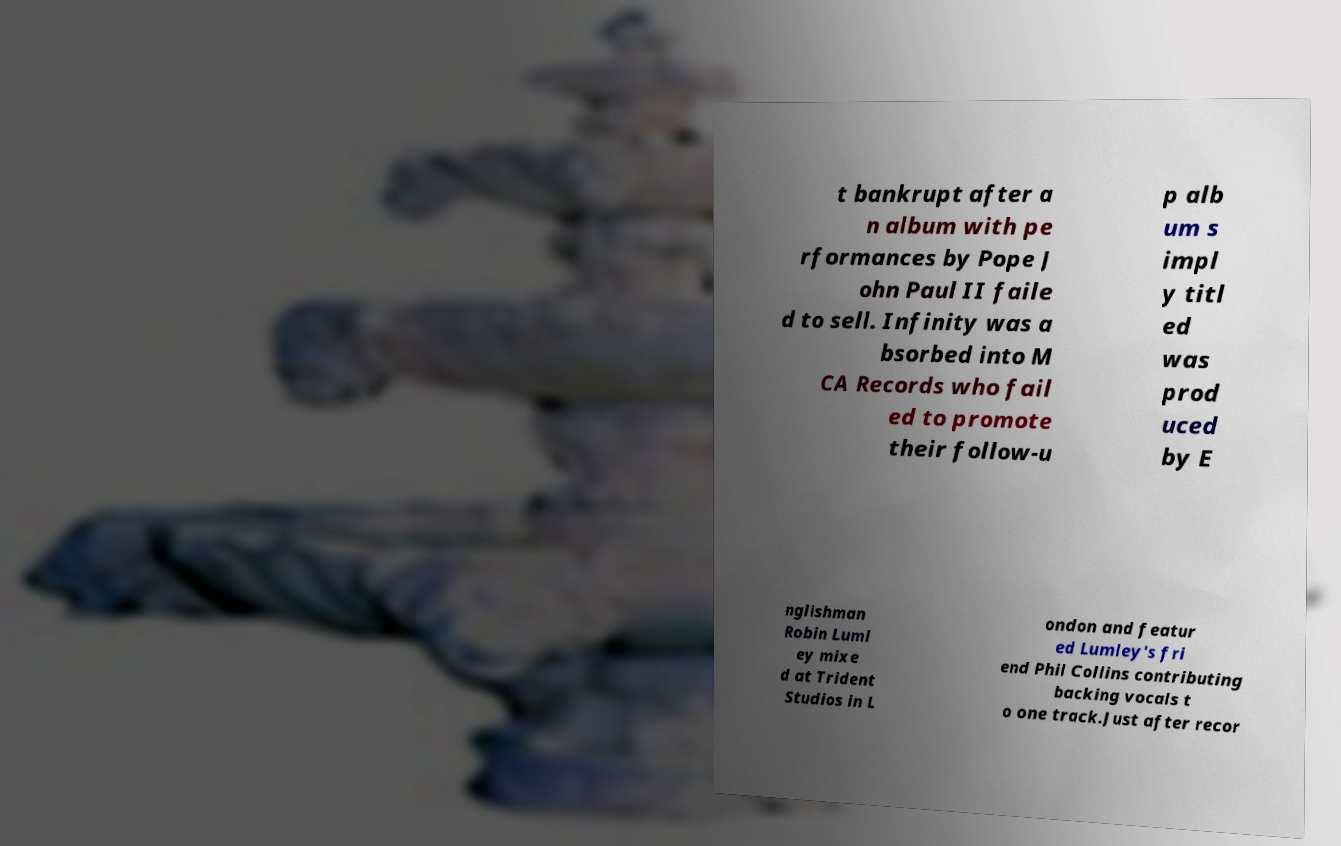There's text embedded in this image that I need extracted. Can you transcribe it verbatim? t bankrupt after a n album with pe rformances by Pope J ohn Paul II faile d to sell. Infinity was a bsorbed into M CA Records who fail ed to promote their follow-u p alb um s impl y titl ed was prod uced by E nglishman Robin Luml ey mixe d at Trident Studios in L ondon and featur ed Lumley's fri end Phil Collins contributing backing vocals t o one track.Just after recor 